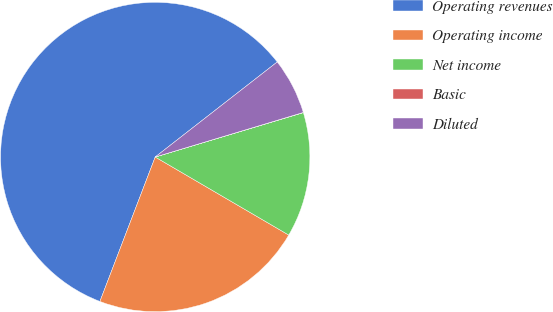Convert chart. <chart><loc_0><loc_0><loc_500><loc_500><pie_chart><fcel>Operating revenues<fcel>Operating income<fcel>Net income<fcel>Basic<fcel>Diluted<nl><fcel>58.65%<fcel>22.4%<fcel>13.05%<fcel>0.02%<fcel>5.88%<nl></chart> 